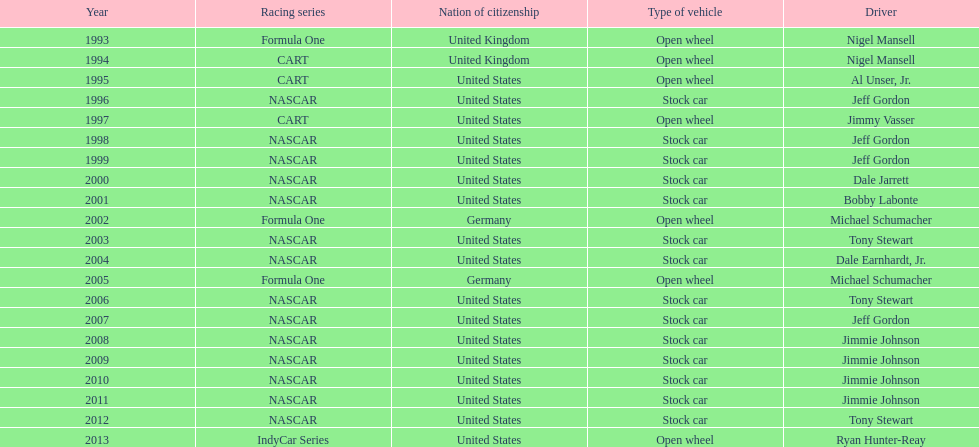How many total row entries are there? 21. 